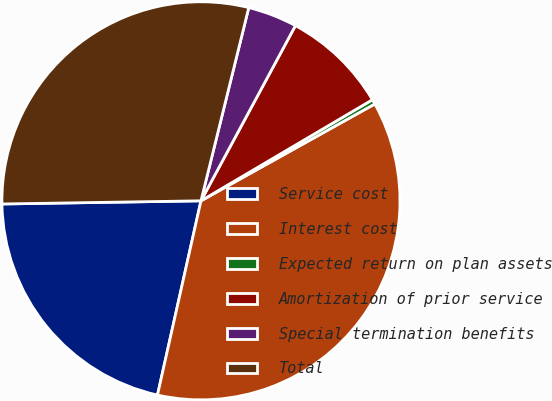Convert chart to OTSL. <chart><loc_0><loc_0><loc_500><loc_500><pie_chart><fcel>Service cost<fcel>Interest cost<fcel>Expected return on plan assets<fcel>Amortization of prior service<fcel>Special termination benefits<fcel>Total<nl><fcel>21.24%<fcel>36.59%<fcel>0.39%<fcel>8.65%<fcel>4.01%<fcel>29.11%<nl></chart> 